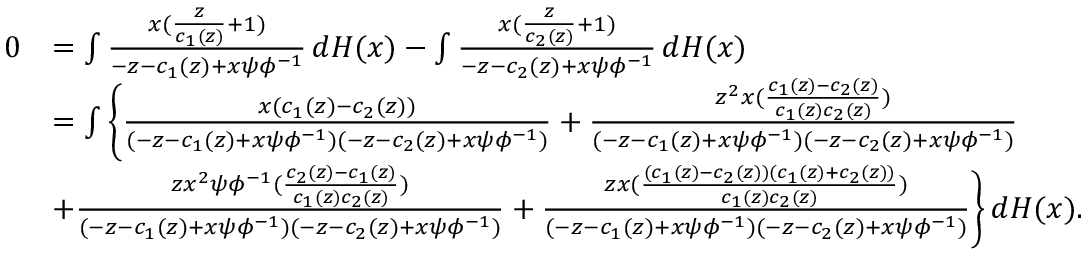Convert formula to latex. <formula><loc_0><loc_0><loc_500><loc_500>\begin{array} { r l } { 0 } & { = \int \frac { x ( \frac { z } { c _ { 1 } ( z ) } + 1 ) } { - z - c _ { 1 } ( z ) + x \psi \phi ^ { - 1 } } \, d H ( x ) - \int \frac { x ( \frac { z } { c _ { 2 } ( z ) } + 1 ) } { - z - c _ { 2 } ( z ) + x \psi \phi ^ { - 1 } } \, d H ( x ) } \\ & { = \int \left \{ \frac { x ( c _ { 1 } ( z ) - c _ { 2 } ( z ) ) } { ( - z - c _ { 1 } ( z ) + x \psi \phi ^ { - 1 } ) ( - z - c _ { 2 } ( z ) + x \psi \phi ^ { - 1 } ) } + \frac { z ^ { 2 } x ( \frac { c _ { 1 } ( z ) - c _ { 2 } ( z ) } { c _ { 1 } ( z ) c _ { 2 } ( z ) } ) } { ( - z - c _ { 1 } ( z ) + x \psi \phi ^ { - 1 } ) ( - z - c _ { 2 } ( z ) + x \psi \phi ^ { - 1 } ) } } \\ & { + \frac { z x ^ { 2 } \psi \phi ^ { - 1 } ( \frac { c _ { 2 } ( z ) - c _ { 1 } ( z ) } { c _ { 1 } ( z ) c _ { 2 } ( z ) } ) } { ( - z - c _ { 1 } ( z ) + x \psi \phi ^ { - 1 } ) ( - z - c _ { 2 } ( z ) + x \psi \phi ^ { - 1 } ) } + \frac { z x ( \frac { ( c _ { 1 } ( z ) - c _ { 2 } ( z ) ) ( c _ { 1 } ( z ) + c _ { 2 } ( z ) ) } { c _ { 1 } ( z ) c _ { 2 } ( z ) } ) } { ( - z - c _ { 1 } ( z ) + x \psi \phi ^ { - 1 } ) ( - z - c _ { 2 } ( z ) + x \psi \phi ^ { - 1 } ) } \right \} \, d H ( x ) . } \end{array}</formula> 